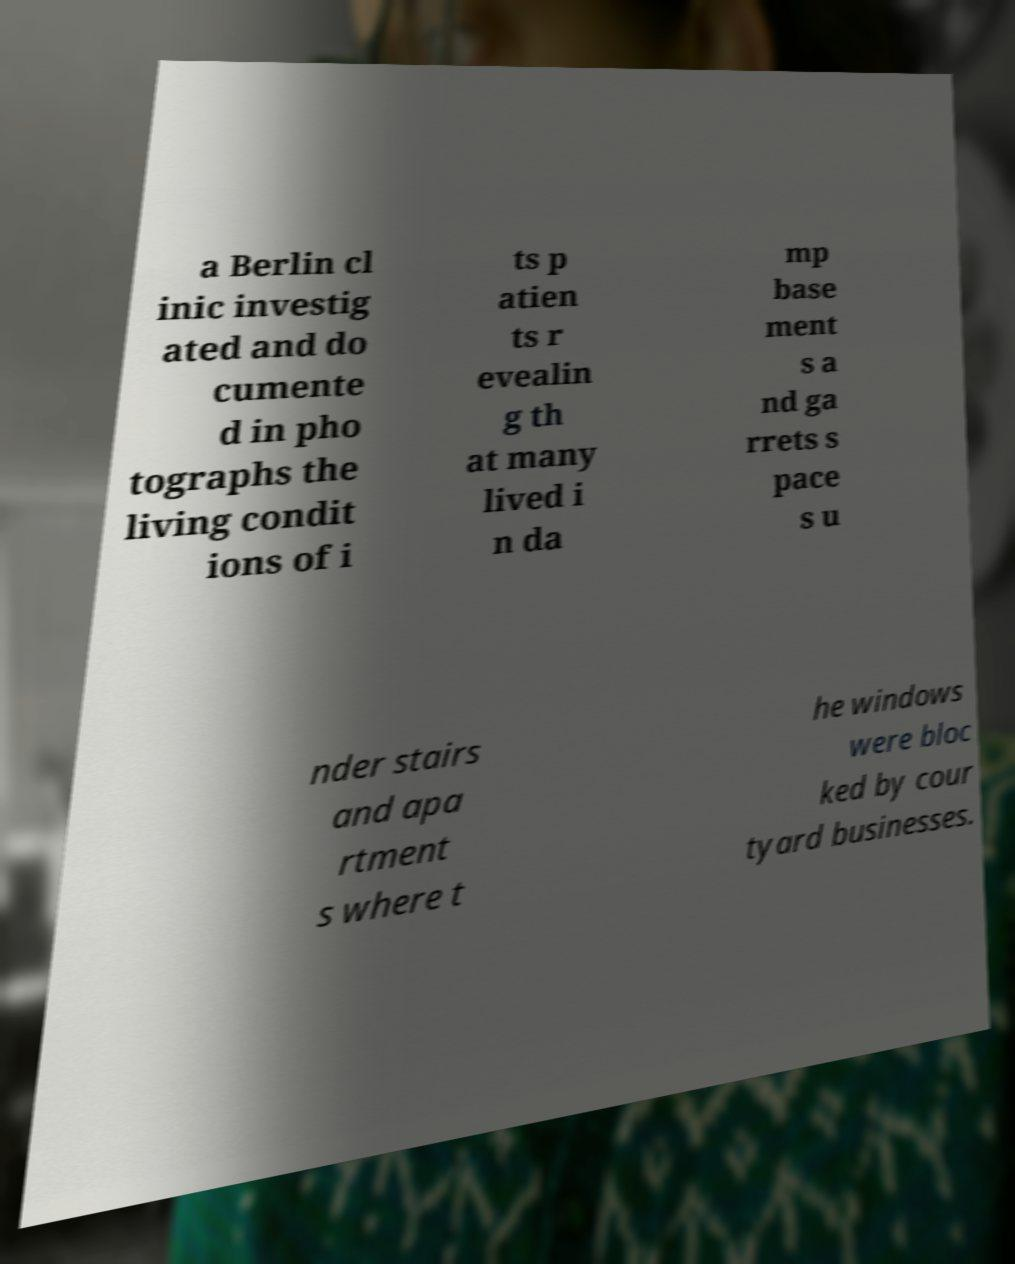For documentation purposes, I need the text within this image transcribed. Could you provide that? a Berlin cl inic investig ated and do cumente d in pho tographs the living condit ions of i ts p atien ts r evealin g th at many lived i n da mp base ment s a nd ga rrets s pace s u nder stairs and apa rtment s where t he windows were bloc ked by cour tyard businesses. 